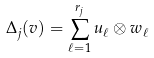<formula> <loc_0><loc_0><loc_500><loc_500>\Delta _ { j } ( v ) = \sum _ { \ell = 1 } ^ { r _ { j } } u _ { \ell } \otimes w _ { \ell }</formula> 